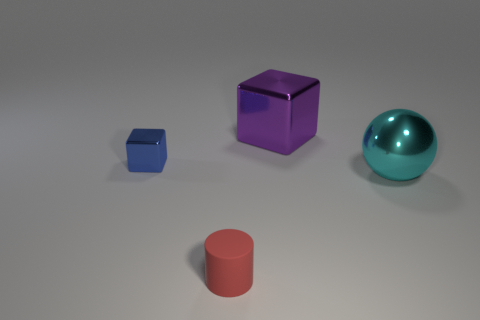How many small red objects are there?
Provide a short and direct response. 1. There is a large object that is to the left of the big shiny sphere; what shape is it?
Your answer should be compact. Cube. The metallic thing right of the big thing that is on the left side of the big shiny object that is in front of the purple thing is what color?
Your answer should be compact. Cyan. What is the shape of the small blue object that is the same material as the cyan sphere?
Offer a very short reply. Cube. Is the number of small red objects less than the number of small objects?
Your answer should be compact. Yes. Is the material of the blue thing the same as the red cylinder?
Provide a succinct answer. No. What number of other objects are there of the same color as the large metallic cube?
Offer a very short reply. 0. Is the number of matte objects greater than the number of purple rubber cylinders?
Give a very brief answer. Yes. Is the size of the red cylinder the same as the purple metallic thing behind the cyan object?
Provide a succinct answer. No. What is the color of the cube that is on the left side of the big shiny cube?
Provide a short and direct response. Blue. 